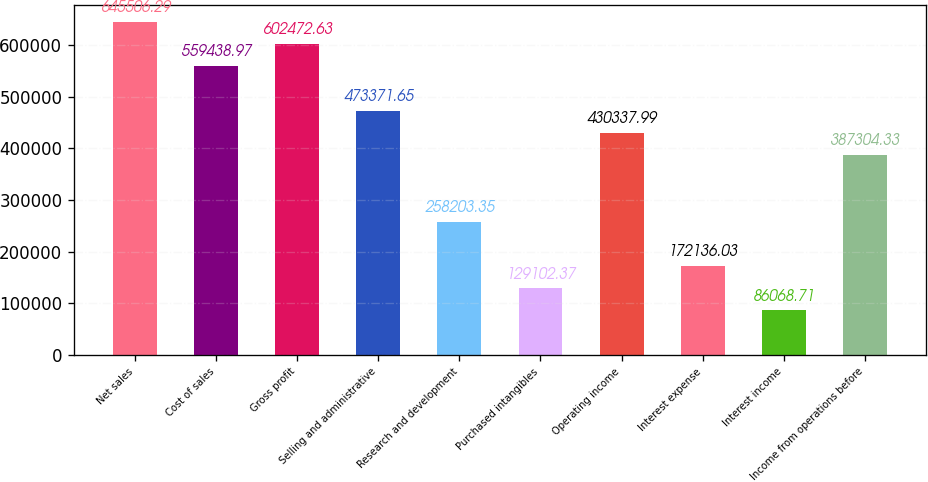Convert chart to OTSL. <chart><loc_0><loc_0><loc_500><loc_500><bar_chart><fcel>Net sales<fcel>Cost of sales<fcel>Gross profit<fcel>Selling and administrative<fcel>Research and development<fcel>Purchased intangibles<fcel>Operating income<fcel>Interest expense<fcel>Interest income<fcel>Income from operations before<nl><fcel>645506<fcel>559439<fcel>602473<fcel>473372<fcel>258203<fcel>129102<fcel>430338<fcel>172136<fcel>86068.7<fcel>387304<nl></chart> 